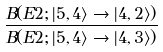Convert formula to latex. <formula><loc_0><loc_0><loc_500><loc_500>\frac { B ( E 2 ; | 5 , 4 \rangle \rightarrow | 4 , 2 \rangle ) } { B ( E 2 ; | 5 , 4 \rangle \rightarrow | 4 , 3 \rangle ) }</formula> 